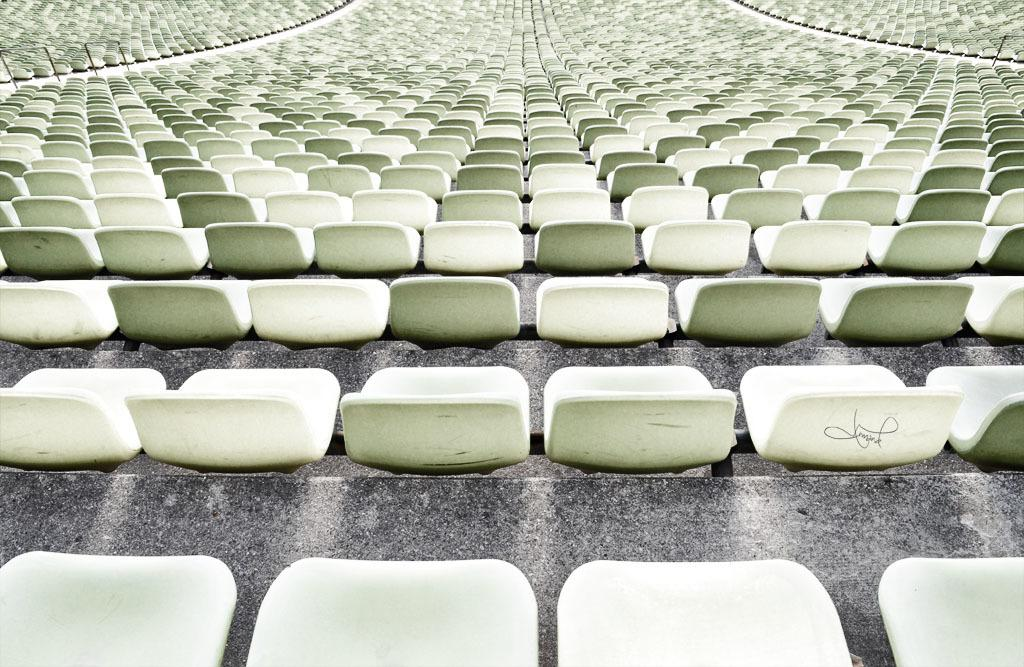What type of furniture is present in the image? There are chairs in the image. What other objects can be seen in the image besides chairs? There are rods and poles in the image. What type of education is being taught in the image? There is no indication of any educational activity or subject in the image. 